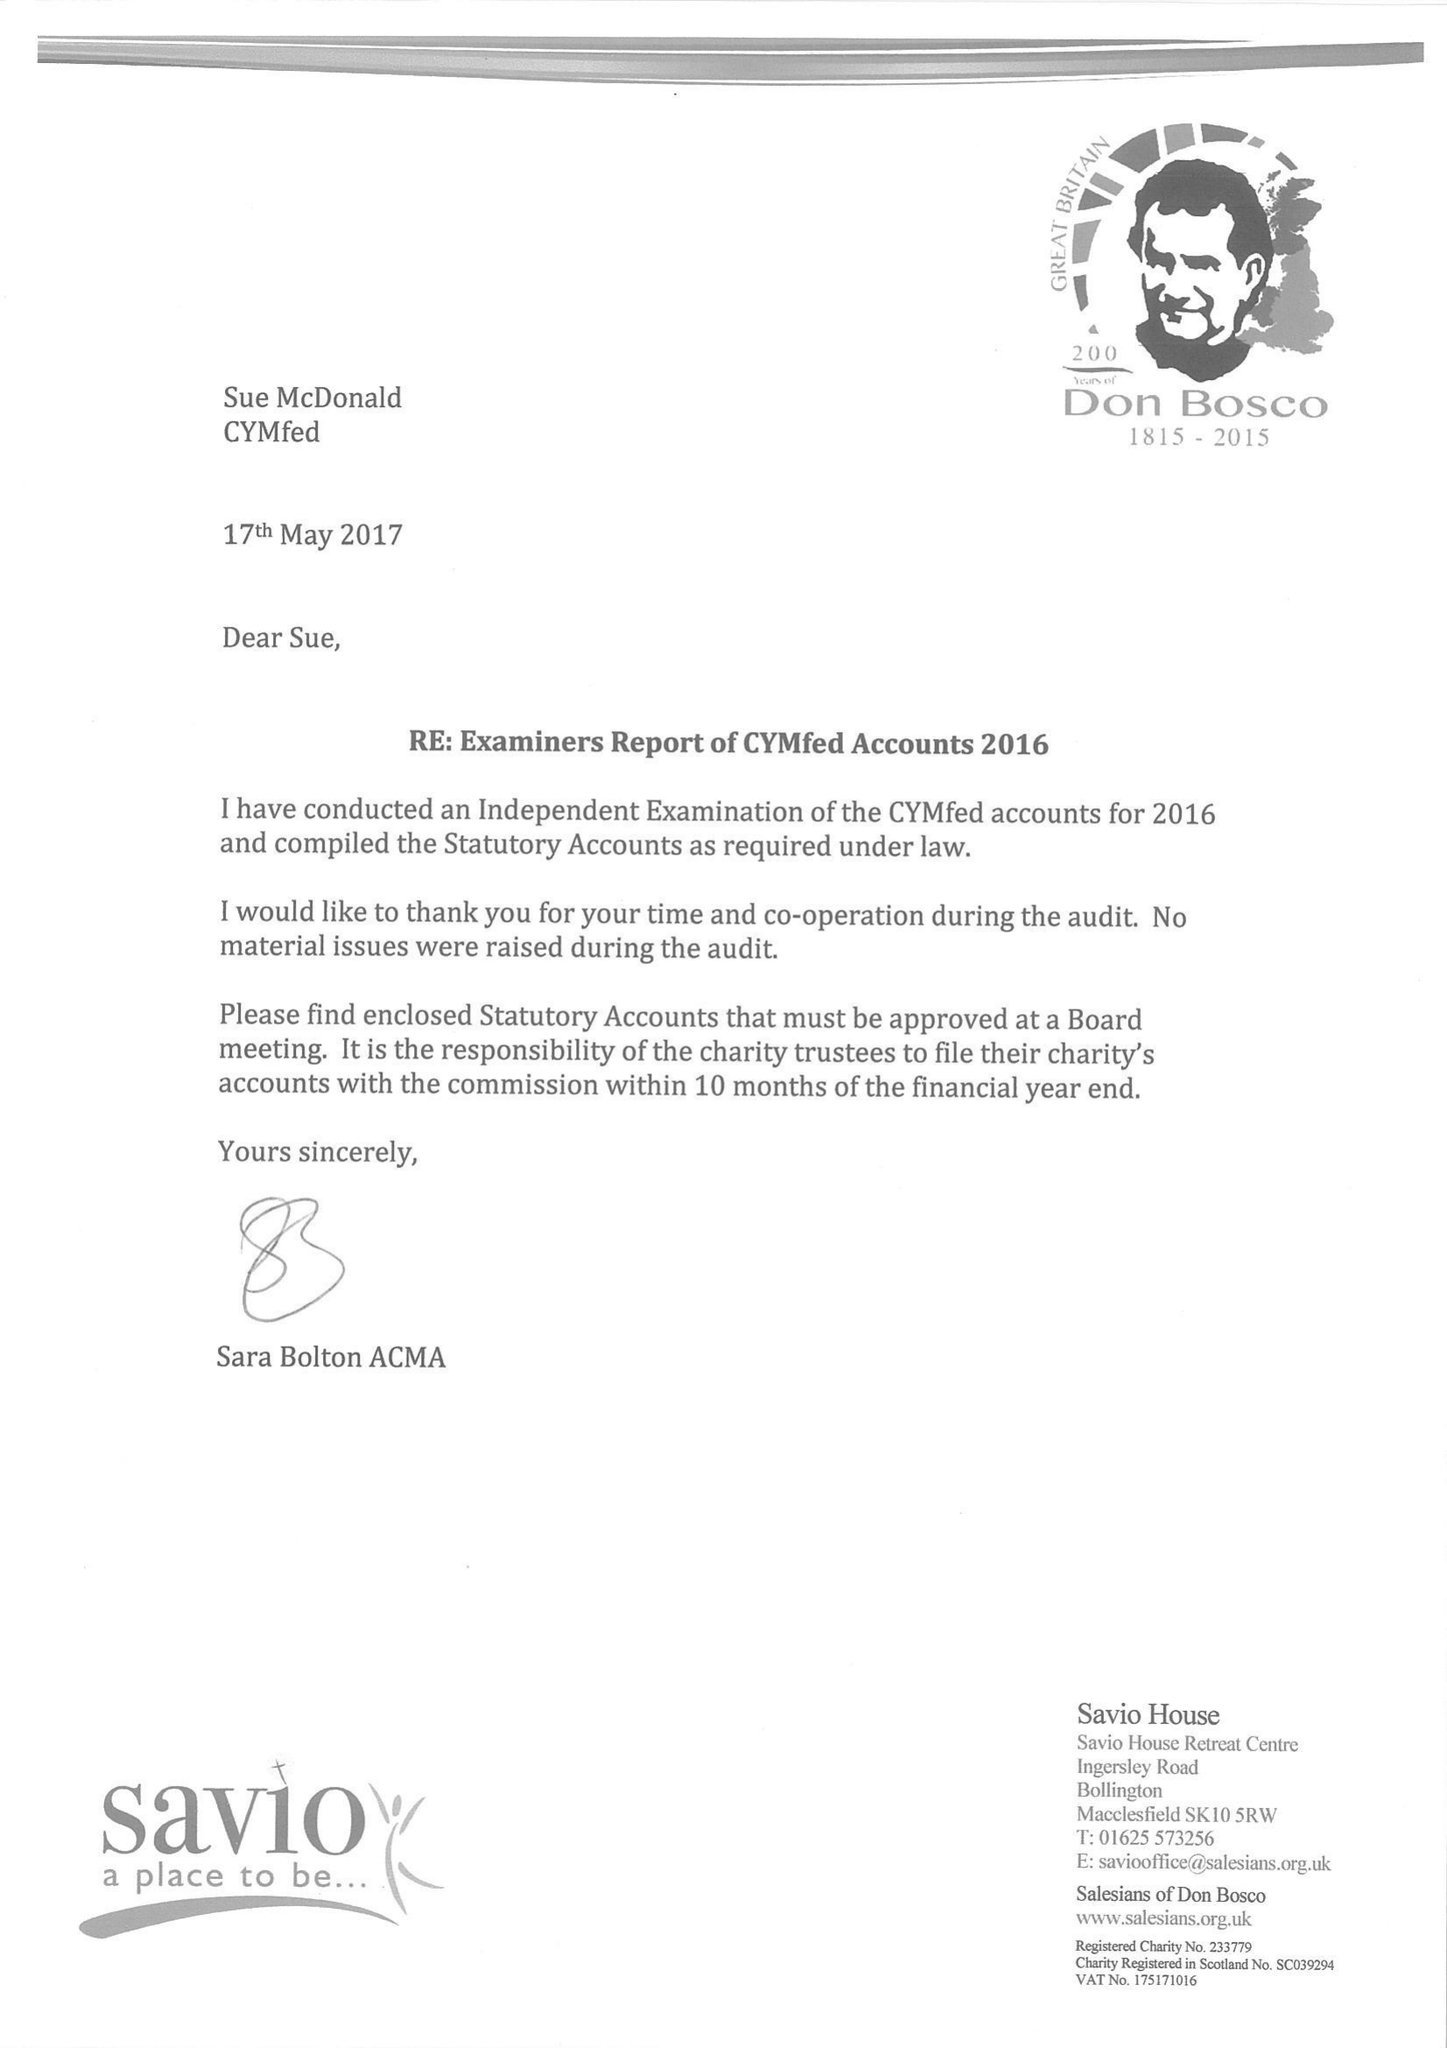What is the value for the report_date?
Answer the question using a single word or phrase. 2016-12-31 